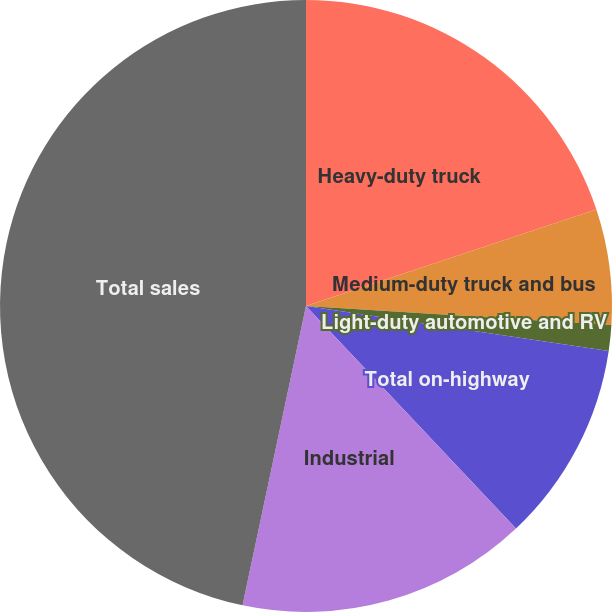<chart> <loc_0><loc_0><loc_500><loc_500><pie_chart><fcel>Heavy-duty truck<fcel>Medium-duty truck and bus<fcel>Light-duty automotive and RV<fcel>Total on-highway<fcel>Industrial<fcel>Total sales<nl><fcel>19.89%<fcel>6.09%<fcel>1.36%<fcel>10.62%<fcel>15.36%<fcel>46.67%<nl></chart> 